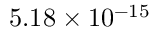<formula> <loc_0><loc_0><loc_500><loc_500>5 . 1 8 \times 1 0 ^ { - 1 5 }</formula> 